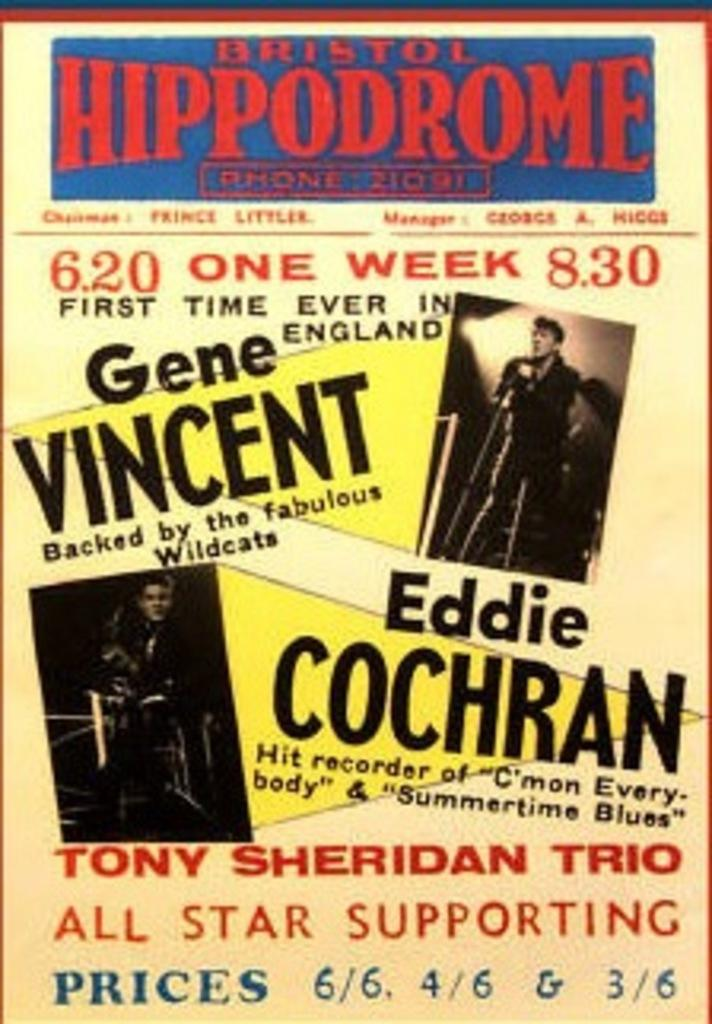What is featured in the picture? There is a poster in the picture. What can be seen on the poster? There are two persons on the poster, and a man is holding a microphone. Is there any text on the poster? Yes, there is text on the poster. Can you tell me how many snails are crawling on the poster? There are no snails present on the poster; it features two persons and a man holding a microphone. 